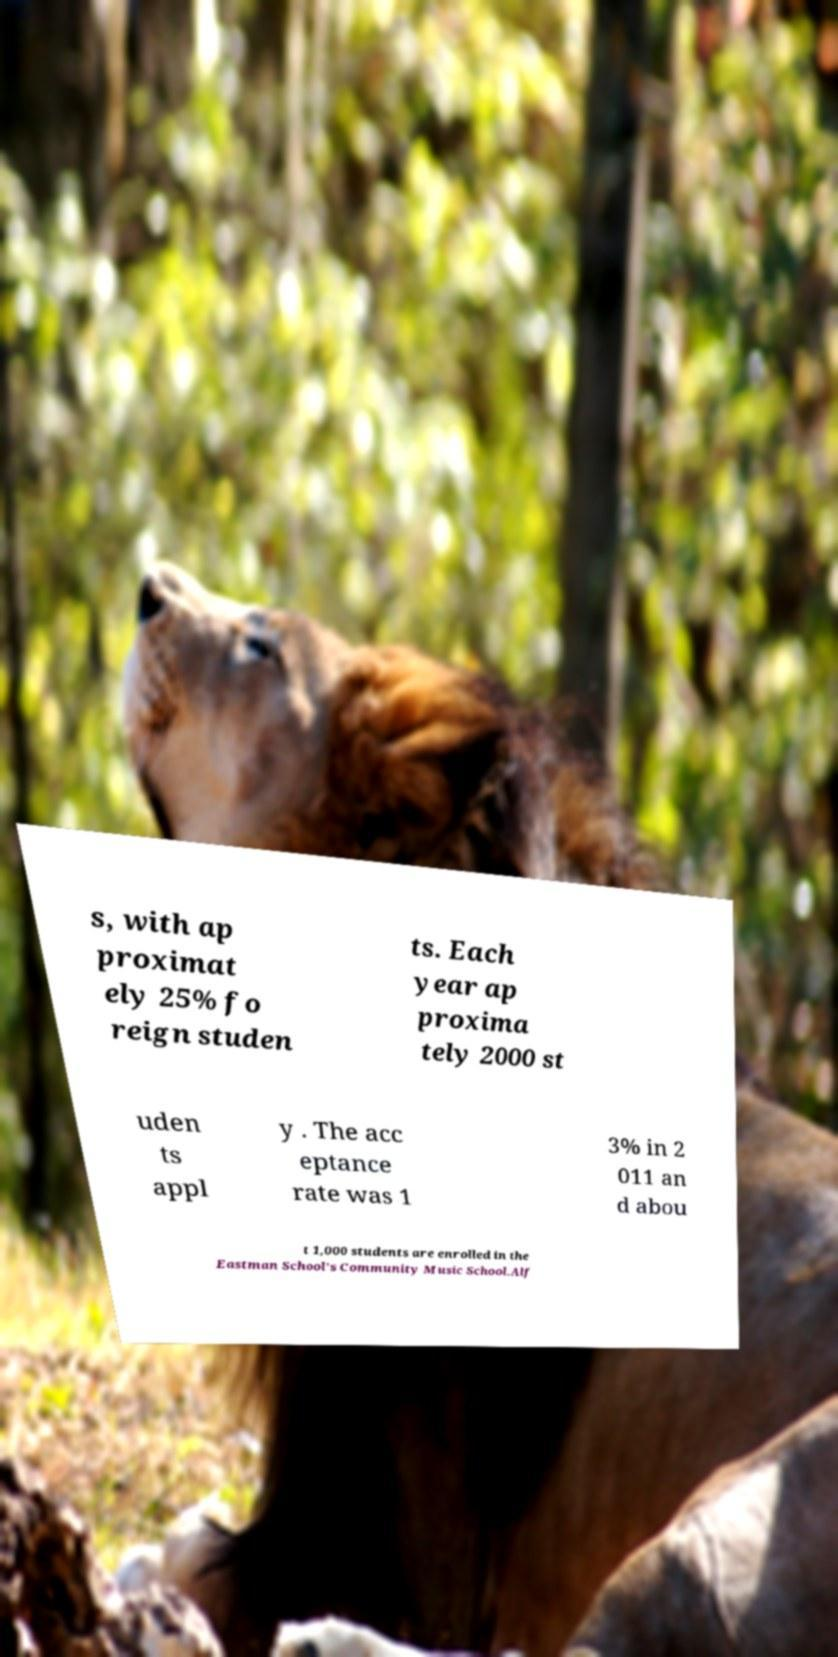There's text embedded in this image that I need extracted. Can you transcribe it verbatim? s, with ap proximat ely 25% fo reign studen ts. Each year ap proxima tely 2000 st uden ts appl y . The acc eptance rate was 1 3% in 2 011 an d abou t 1,000 students are enrolled in the Eastman School’s Community Music School.Alf 